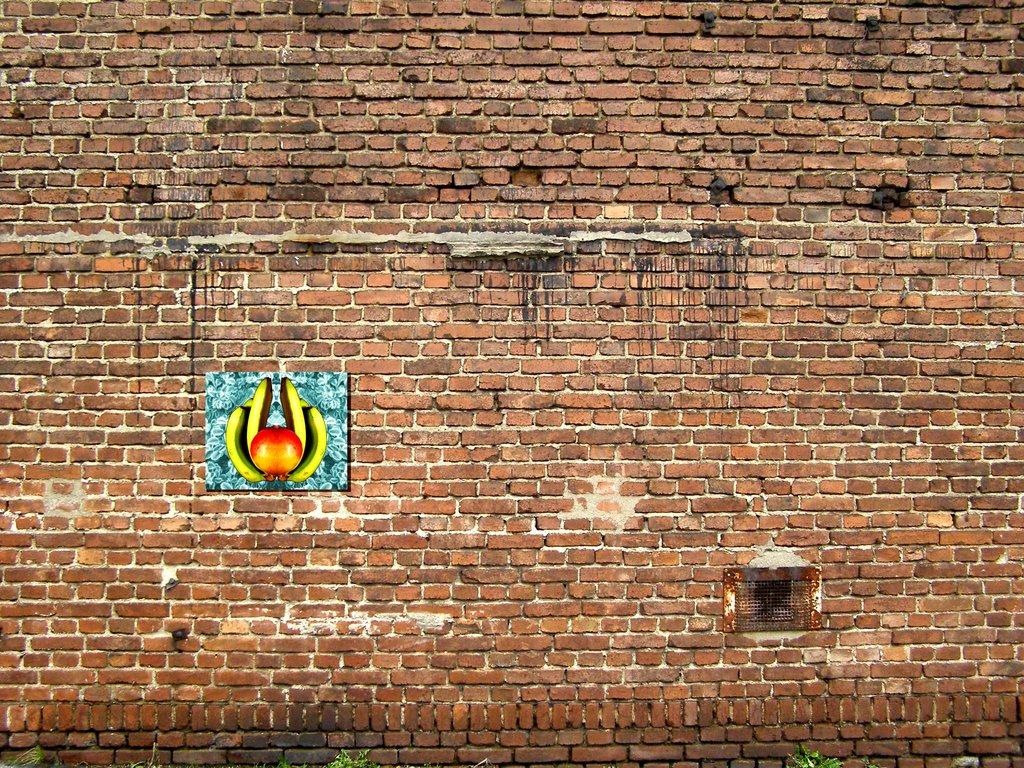What is attached to the brick wall in the image? There is a board on the brick wall in the image. What else can be seen on the brick wall? There is mesh present on the brick wall in the image. What type of vegetation is visible at the bottom of the image? Plants are visible at the bottom of the image. What type of crime is being committed in the image? There is no indication of any crime being committed in the image. How does the board on the brick wall make people laugh in the image? The image does not depict any humor or laughter; it only shows a board and mesh on a brick wall with plants at the bottom. 